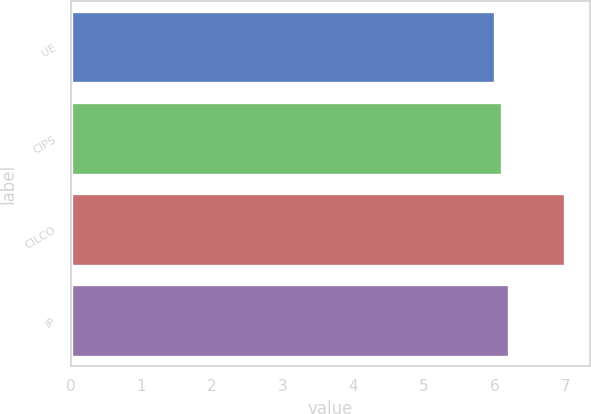<chart> <loc_0><loc_0><loc_500><loc_500><bar_chart><fcel>UE<fcel>CIPS<fcel>CILCO<fcel>IP<nl><fcel>6<fcel>6.1<fcel>7<fcel>6.2<nl></chart> 